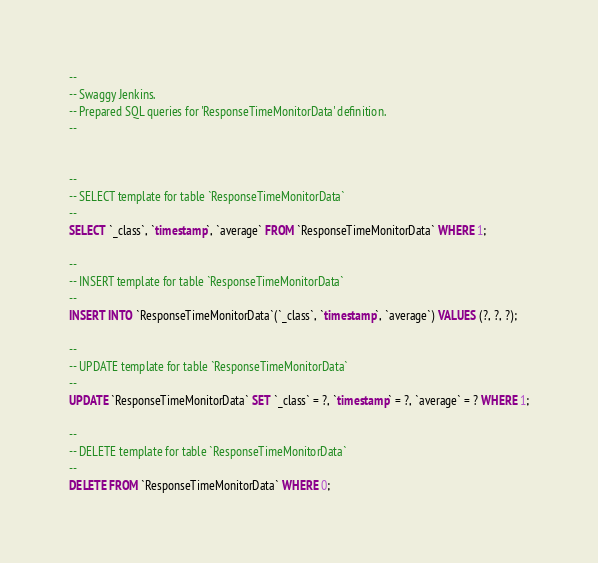<code> <loc_0><loc_0><loc_500><loc_500><_SQL_>--
-- Swaggy Jenkins.
-- Prepared SQL queries for 'ResponseTimeMonitorData' definition.
--


--
-- SELECT template for table `ResponseTimeMonitorData`
--
SELECT `_class`, `timestamp`, `average` FROM `ResponseTimeMonitorData` WHERE 1;

--
-- INSERT template for table `ResponseTimeMonitorData`
--
INSERT INTO `ResponseTimeMonitorData`(`_class`, `timestamp`, `average`) VALUES (?, ?, ?);

--
-- UPDATE template for table `ResponseTimeMonitorData`
--
UPDATE `ResponseTimeMonitorData` SET `_class` = ?, `timestamp` = ?, `average` = ? WHERE 1;

--
-- DELETE template for table `ResponseTimeMonitorData`
--
DELETE FROM `ResponseTimeMonitorData` WHERE 0;

</code> 